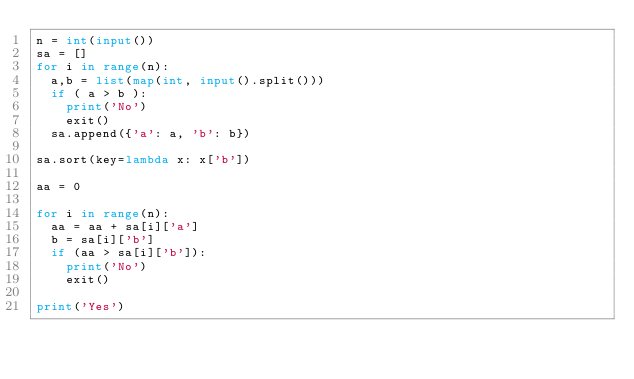Convert code to text. <code><loc_0><loc_0><loc_500><loc_500><_Python_>n = int(input())
sa = []
for i in range(n):
  a,b = list(map(int, input().split()))
  if ( a > b ):
    print('No')
    exit()    
  sa.append({'a': a, 'b': b})

sa.sort(key=lambda x: x['b'])

aa = 0

for i in range(n):
  aa = aa + sa[i]['a']
  b = sa[i]['b']
  if (aa > sa[i]['b']):
    print('No')
    exit()

print('Yes')
</code> 